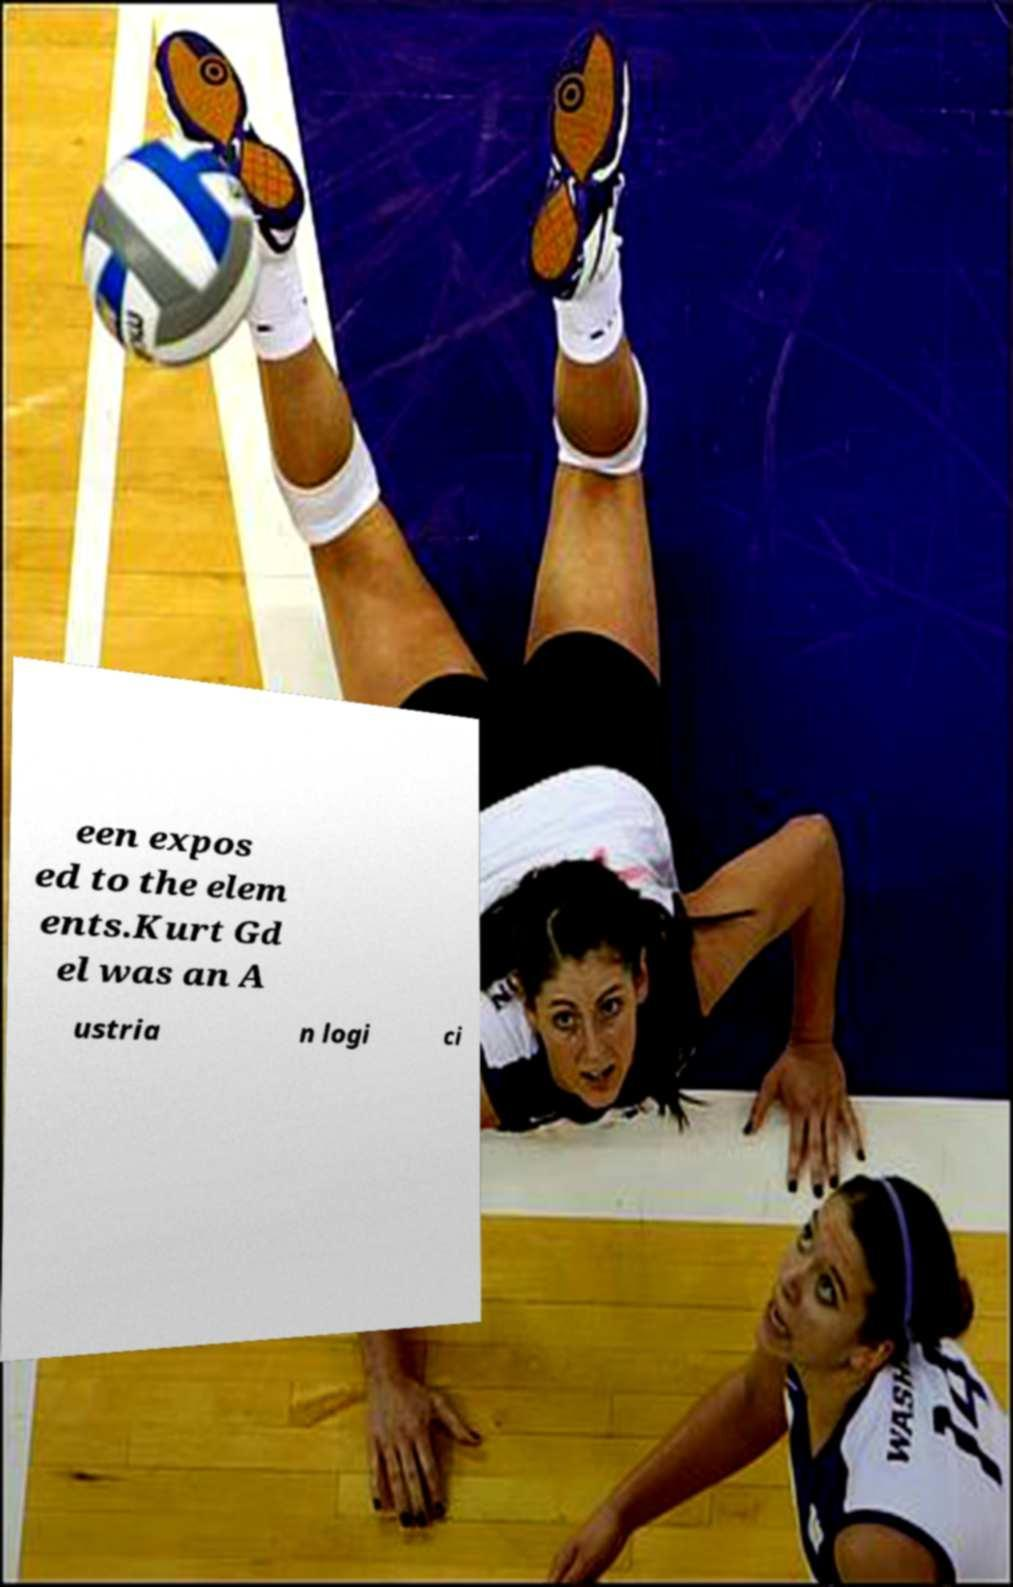Please identify and transcribe the text found in this image. een expos ed to the elem ents.Kurt Gd el was an A ustria n logi ci 